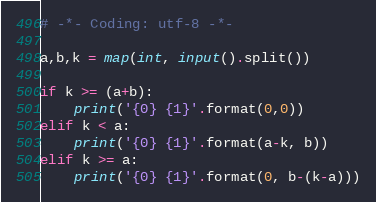<code> <loc_0><loc_0><loc_500><loc_500><_Python_># -*- Coding: utf-8 -*-

a,b,k = map(int, input().split())

if k >= (a+b):
    print('{0} {1}'.format(0,0))
elif k < a:
    print('{0} {1}'.format(a-k, b))
elif k >= a:
    print('{0} {1}'.format(0, b-(k-a)))</code> 